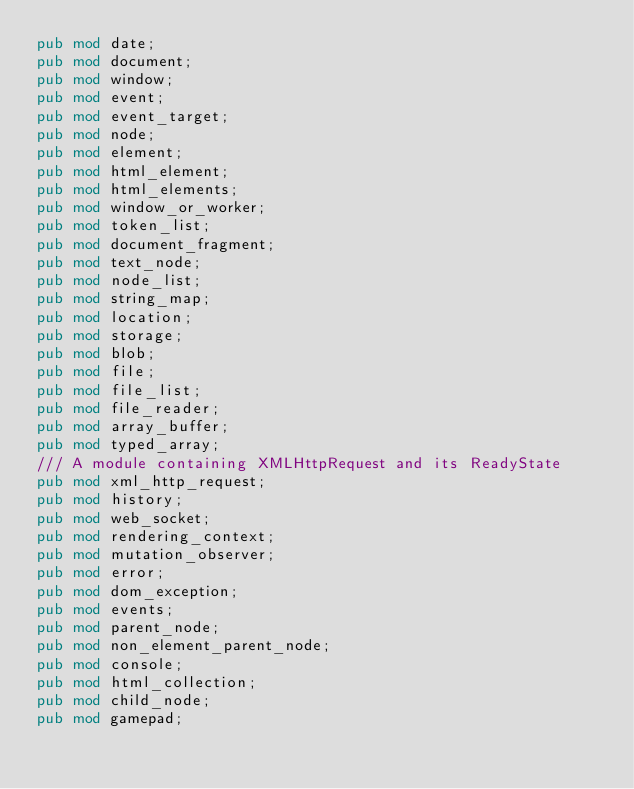Convert code to text. <code><loc_0><loc_0><loc_500><loc_500><_Rust_>pub mod date;
pub mod document;
pub mod window;
pub mod event;
pub mod event_target;
pub mod node;
pub mod element;
pub mod html_element;
pub mod html_elements;
pub mod window_or_worker;
pub mod token_list;
pub mod document_fragment;
pub mod text_node;
pub mod node_list;
pub mod string_map;
pub mod location;
pub mod storage;
pub mod blob;
pub mod file;
pub mod file_list;
pub mod file_reader;
pub mod array_buffer;
pub mod typed_array;
/// A module containing XMLHttpRequest and its ReadyState
pub mod xml_http_request;
pub mod history;
pub mod web_socket;
pub mod rendering_context;
pub mod mutation_observer;
pub mod error;
pub mod dom_exception;
pub mod events;
pub mod parent_node;
pub mod non_element_parent_node;
pub mod console;
pub mod html_collection;
pub mod child_node;
pub mod gamepad;
</code> 